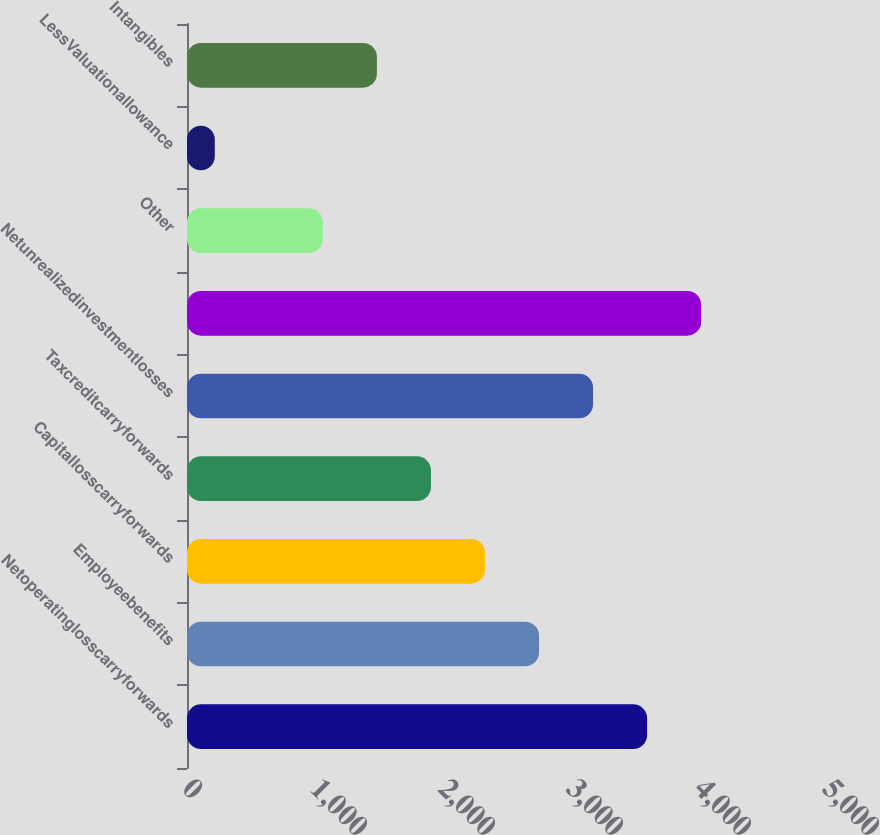Convert chart to OTSL. <chart><loc_0><loc_0><loc_500><loc_500><bar_chart><fcel>Netoperatinglosscarryforwards<fcel>Employeebenefits<fcel>Capitallosscarryforwards<fcel>Taxcreditcarryforwards<fcel>Netunrealizedinvestmentlosses<fcel>Unnamed: 5<fcel>Other<fcel>LessValuationallowance<fcel>Intangibles<nl><fcel>3594.6<fcel>2750.2<fcel>2328<fcel>1905.8<fcel>3172.4<fcel>4016.8<fcel>1061.4<fcel>217<fcel>1483.6<nl></chart> 